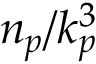<formula> <loc_0><loc_0><loc_500><loc_500>n _ { p } / k _ { p } ^ { 3 }</formula> 